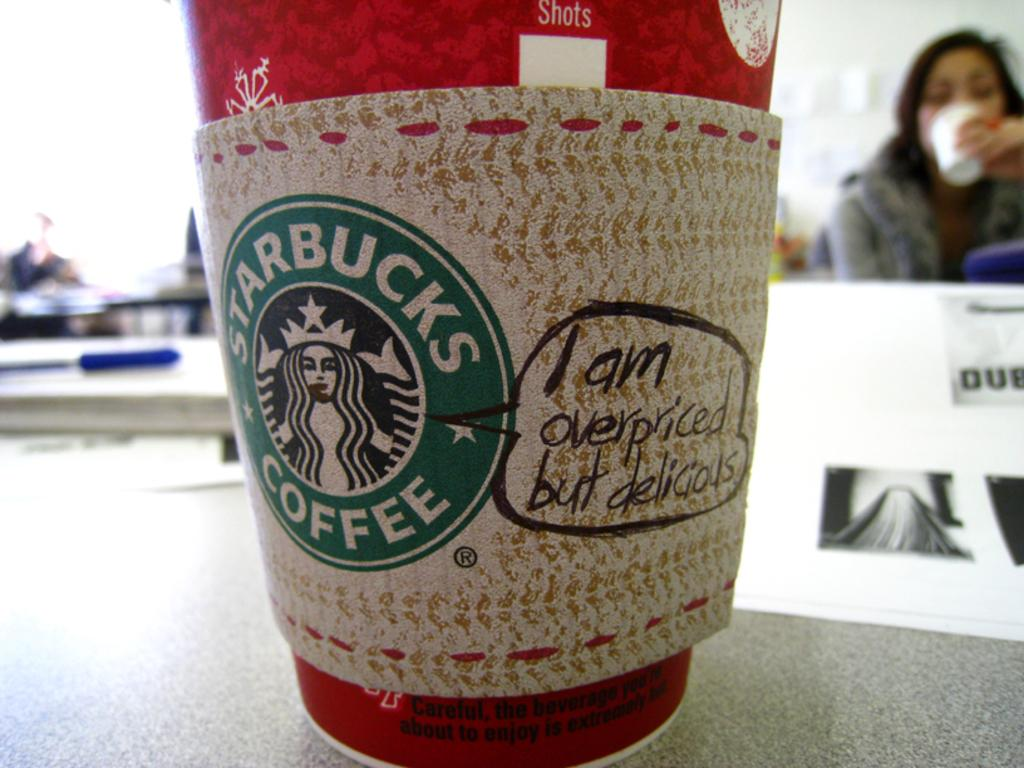What can be seen in the image related to a beverage? There is a coffee cup in the image. What is unique about the coffee cup? The coffee cup has text written on it. Who is present in the image? There is a woman in the image. What is the woman holding? The woman is holding an object. What thought is the woman's aunt having while looking at the wheel in the image? There is no mention of a wheel, an aunt, or any thoughts in the image. 